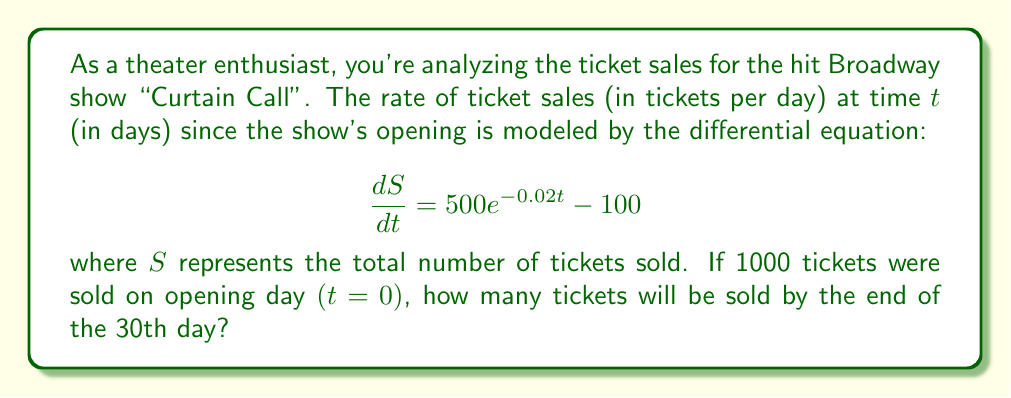What is the answer to this math problem? To solve this problem, we need to follow these steps:

1) First, we need to solve the differential equation to find $S(t)$. The equation is in the form:

   $$\frac{dS}{dt} = 500e^{-0.02t} - 100$$

2) To solve this, we integrate both sides with respect to $t$:

   $$S = \int (500e^{-0.02t} - 100) dt$$

3) Integrating the right side:

   $$S = -25000e^{-0.02t} - 100t + C$$

   where $C$ is the constant of integration.

4) To find $C$, we use the initial condition: $S(0) = 1000$

   $$1000 = -25000e^0 - 100(0) + C$$
   $$1000 = -25000 + C$$
   $$C = 26000$$

5) So, our solution is:

   $$S(t) = -25000e^{-0.02t} - 100t + 26000$$

6) Now, we need to find $S(30)$:

   $$S(30) = -25000e^{-0.02(30)} - 100(30) + 26000$$
   $$= -25000e^{-0.6} - 3000 + 26000$$
   $$= -25000(0.5488) - 3000 + 26000$$
   $$= -13720 - 3000 + 26000$$
   $$= 9280$$

Therefore, by the end of the 30th day, 9280 tickets will have been sold.
Answer: 9280 tickets 